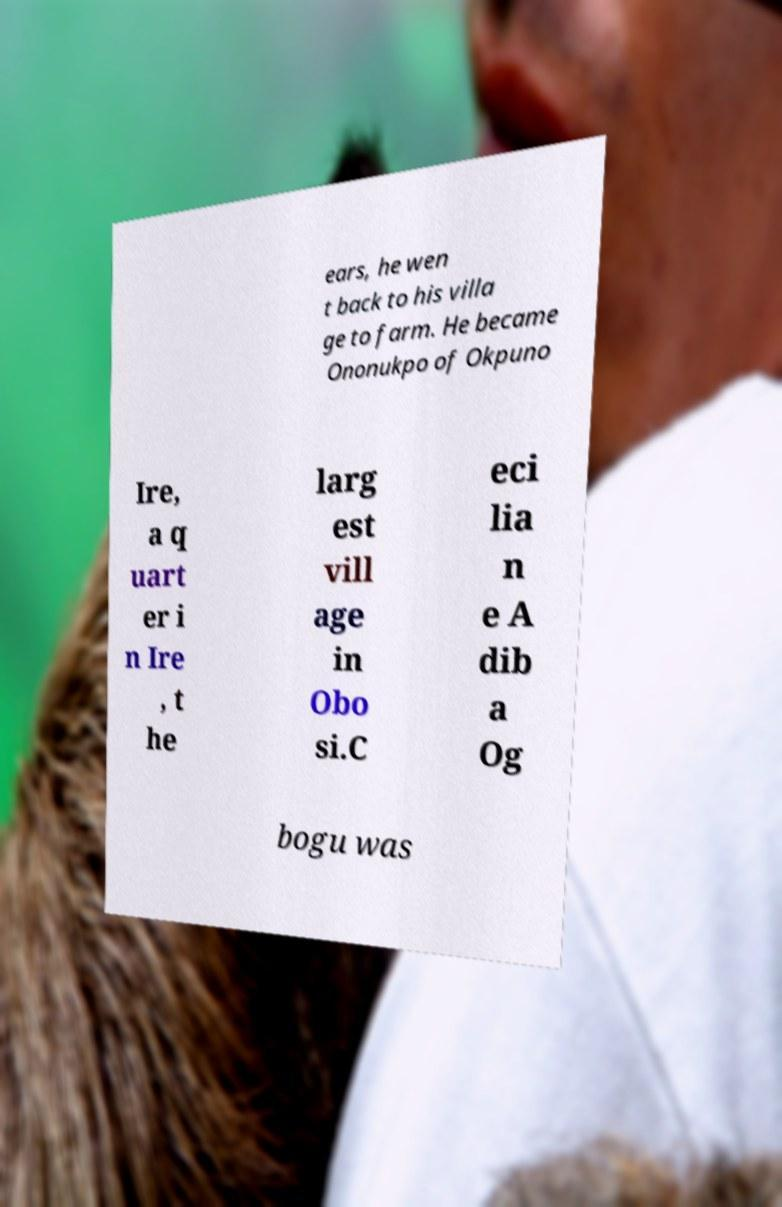Can you accurately transcribe the text from the provided image for me? ears, he wen t back to his villa ge to farm. He became Ononukpo of Okpuno Ire, a q uart er i n Ire , t he larg est vill age in Obo si.C eci lia n e A dib a Og bogu was 